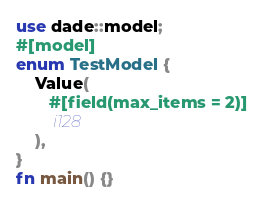<code> <loc_0><loc_0><loc_500><loc_500><_Rust_>use dade::model;
#[model]
enum TestModel {
    Value(
       #[field(max_items = 2)]
        i128
    ),
}
fn main() {}
</code> 